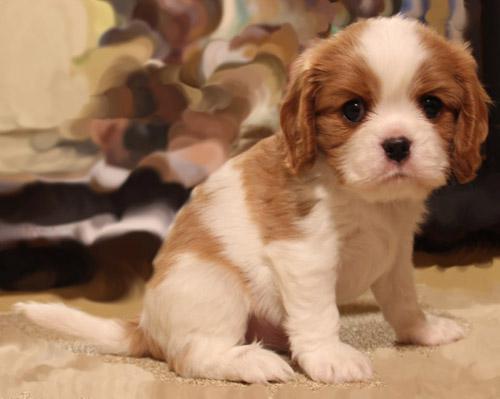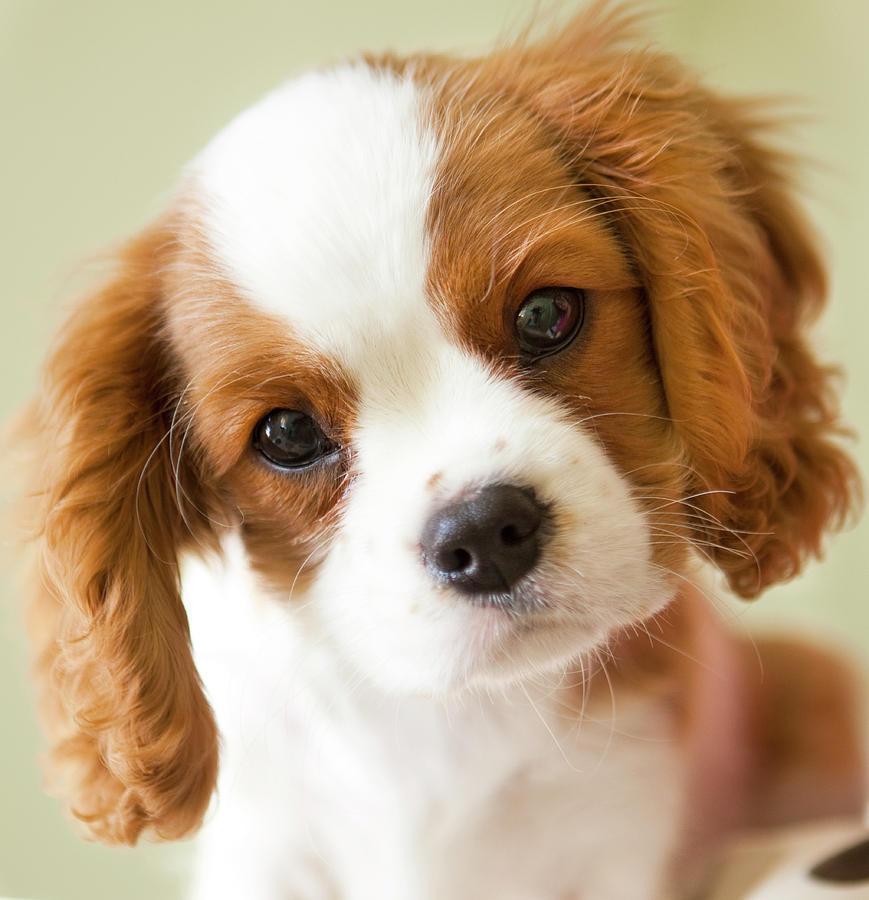The first image is the image on the left, the second image is the image on the right. Considering the images on both sides, is "At least one dog is laying down." valid? Answer yes or no. No. 